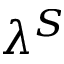Convert formula to latex. <formula><loc_0><loc_0><loc_500><loc_500>\lambda ^ { S }</formula> 